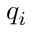<formula> <loc_0><loc_0><loc_500><loc_500>q _ { i }</formula> 